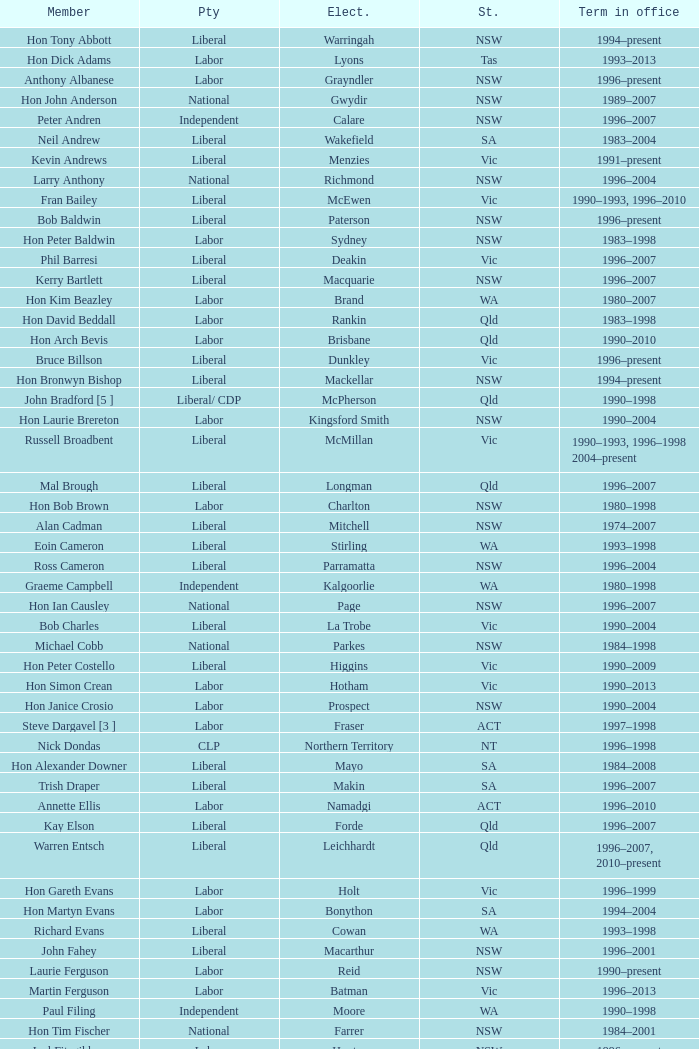What state did Hon David Beddall belong to? Qld. 